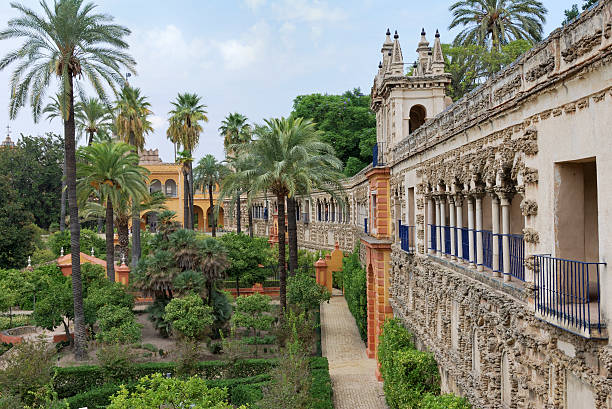What is this photo about'? The image captures the breathtaking view of the Alcazar Cathedral Gardens in Seville, Spain. The vantage point is high, offering a panoramic perspective of the gardens below. The gardens are a vibrant display of lush greenery, with palm trees and bushes dotting the landscape. Stone buildings, rich in ornate details, add a touch of historical grandeur to the scene. The color palette is dominated by the verdant greens of the vegetation and the beige tones of the stone structures, with hints of blue from the sky and railings adding a refreshing contrast. This image encapsulates the serene beauty and architectural splendor of this renowned landmark. 